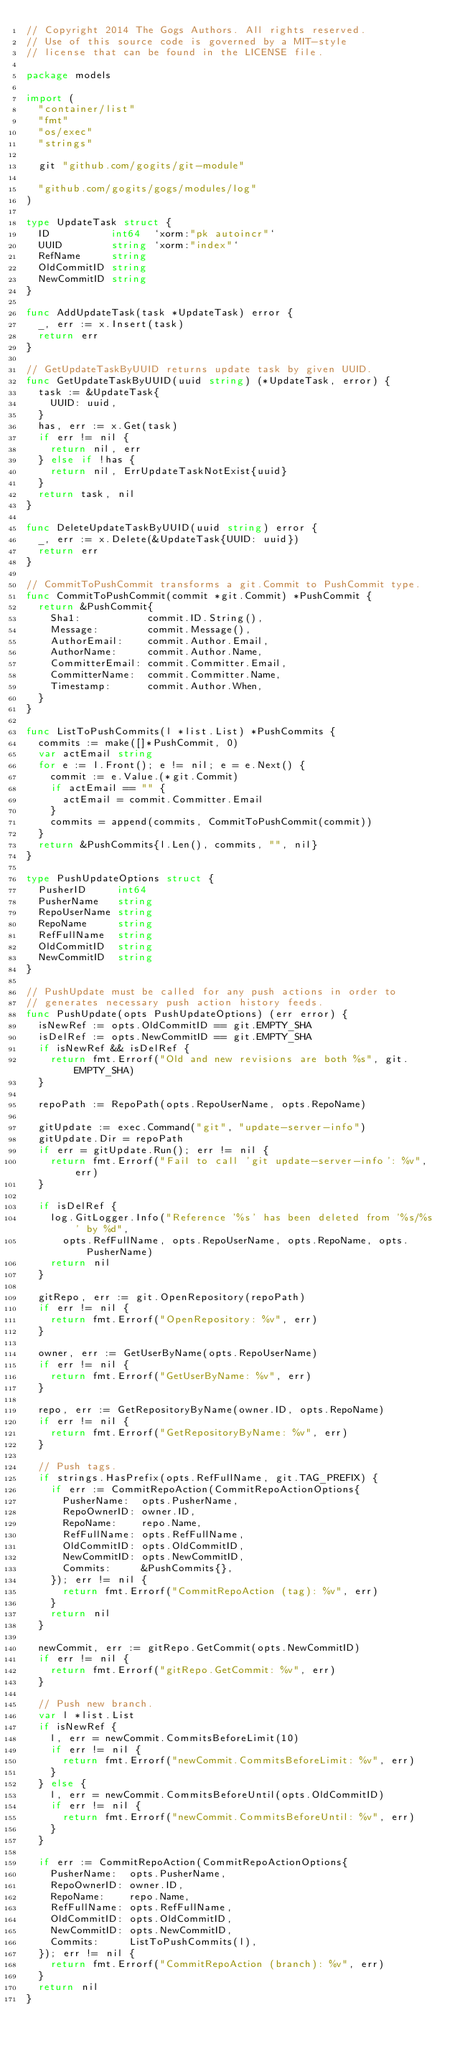Convert code to text. <code><loc_0><loc_0><loc_500><loc_500><_Go_>// Copyright 2014 The Gogs Authors. All rights reserved.
// Use of this source code is governed by a MIT-style
// license that can be found in the LICENSE file.

package models

import (
	"container/list"
	"fmt"
	"os/exec"
	"strings"

	git "github.com/gogits/git-module"

	"github.com/gogits/gogs/modules/log"
)

type UpdateTask struct {
	ID          int64  `xorm:"pk autoincr"`
	UUID        string `xorm:"index"`
	RefName     string
	OldCommitID string
	NewCommitID string
}

func AddUpdateTask(task *UpdateTask) error {
	_, err := x.Insert(task)
	return err
}

// GetUpdateTaskByUUID returns update task by given UUID.
func GetUpdateTaskByUUID(uuid string) (*UpdateTask, error) {
	task := &UpdateTask{
		UUID: uuid,
	}
	has, err := x.Get(task)
	if err != nil {
		return nil, err
	} else if !has {
		return nil, ErrUpdateTaskNotExist{uuid}
	}
	return task, nil
}

func DeleteUpdateTaskByUUID(uuid string) error {
	_, err := x.Delete(&UpdateTask{UUID: uuid})
	return err
}

// CommitToPushCommit transforms a git.Commit to PushCommit type.
func CommitToPushCommit(commit *git.Commit) *PushCommit {
	return &PushCommit{
		Sha1:           commit.ID.String(),
		Message:        commit.Message(),
		AuthorEmail:    commit.Author.Email,
		AuthorName:     commit.Author.Name,
		CommitterEmail: commit.Committer.Email,
		CommitterName:  commit.Committer.Name,
		Timestamp:      commit.Author.When,
	}
}

func ListToPushCommits(l *list.List) *PushCommits {
	commits := make([]*PushCommit, 0)
	var actEmail string
	for e := l.Front(); e != nil; e = e.Next() {
		commit := e.Value.(*git.Commit)
		if actEmail == "" {
			actEmail = commit.Committer.Email
		}
		commits = append(commits, CommitToPushCommit(commit))
	}
	return &PushCommits{l.Len(), commits, "", nil}
}

type PushUpdateOptions struct {
	PusherID     int64
	PusherName   string
	RepoUserName string
	RepoName     string
	RefFullName  string
	OldCommitID  string
	NewCommitID  string
}

// PushUpdate must be called for any push actions in order to
// generates necessary push action history feeds.
func PushUpdate(opts PushUpdateOptions) (err error) {
	isNewRef := opts.OldCommitID == git.EMPTY_SHA
	isDelRef := opts.NewCommitID == git.EMPTY_SHA
	if isNewRef && isDelRef {
		return fmt.Errorf("Old and new revisions are both %s", git.EMPTY_SHA)
	}

	repoPath := RepoPath(opts.RepoUserName, opts.RepoName)

	gitUpdate := exec.Command("git", "update-server-info")
	gitUpdate.Dir = repoPath
	if err = gitUpdate.Run(); err != nil {
		return fmt.Errorf("Fail to call 'git update-server-info': %v", err)
	}

	if isDelRef {
		log.GitLogger.Info("Reference '%s' has been deleted from '%s/%s' by %d",
			opts.RefFullName, opts.RepoUserName, opts.RepoName, opts.PusherName)
		return nil
	}

	gitRepo, err := git.OpenRepository(repoPath)
	if err != nil {
		return fmt.Errorf("OpenRepository: %v", err)
	}

	owner, err := GetUserByName(opts.RepoUserName)
	if err != nil {
		return fmt.Errorf("GetUserByName: %v", err)
	}

	repo, err := GetRepositoryByName(owner.ID, opts.RepoName)
	if err != nil {
		return fmt.Errorf("GetRepositoryByName: %v", err)
	}

	// Push tags.
	if strings.HasPrefix(opts.RefFullName, git.TAG_PREFIX) {
		if err := CommitRepoAction(CommitRepoActionOptions{
			PusherName:  opts.PusherName,
			RepoOwnerID: owner.ID,
			RepoName:    repo.Name,
			RefFullName: opts.RefFullName,
			OldCommitID: opts.OldCommitID,
			NewCommitID: opts.NewCommitID,
			Commits:     &PushCommits{},
		}); err != nil {
			return fmt.Errorf("CommitRepoAction (tag): %v", err)
		}
		return nil
	}

	newCommit, err := gitRepo.GetCommit(opts.NewCommitID)
	if err != nil {
		return fmt.Errorf("gitRepo.GetCommit: %v", err)
	}

	// Push new branch.
	var l *list.List
	if isNewRef {
		l, err = newCommit.CommitsBeforeLimit(10)
		if err != nil {
			return fmt.Errorf("newCommit.CommitsBeforeLimit: %v", err)
		}
	} else {
		l, err = newCommit.CommitsBeforeUntil(opts.OldCommitID)
		if err != nil {
			return fmt.Errorf("newCommit.CommitsBeforeUntil: %v", err)
		}
	}

	if err := CommitRepoAction(CommitRepoActionOptions{
		PusherName:  opts.PusherName,
		RepoOwnerID: owner.ID,
		RepoName:    repo.Name,
		RefFullName: opts.RefFullName,
		OldCommitID: opts.OldCommitID,
		NewCommitID: opts.NewCommitID,
		Commits:     ListToPushCommits(l),
	}); err != nil {
		return fmt.Errorf("CommitRepoAction (branch): %v", err)
	}
	return nil
}
</code> 